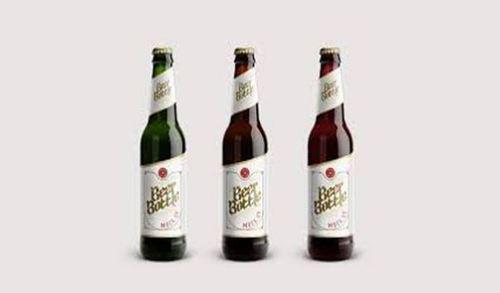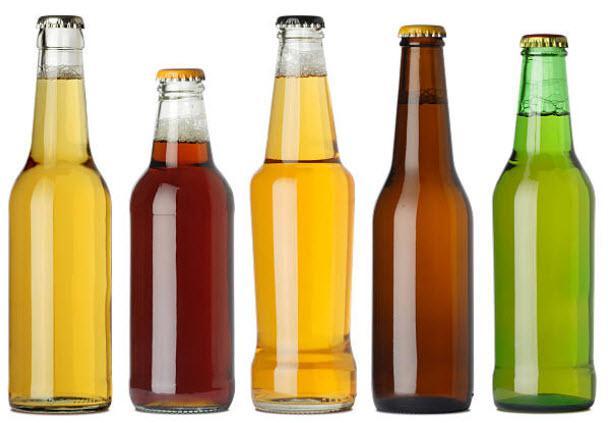The first image is the image on the left, the second image is the image on the right. Examine the images to the left and right. Is the description "In at least one image there are nine bottles of alcohol." accurate? Answer yes or no. No. The first image is the image on the left, the second image is the image on the right. Analyze the images presented: Is the assertion "One image shows a variety of glass bottle shapes, colors and sizes displayed upright on a flat surface, with bottles overlapping." valid? Answer yes or no. No. 